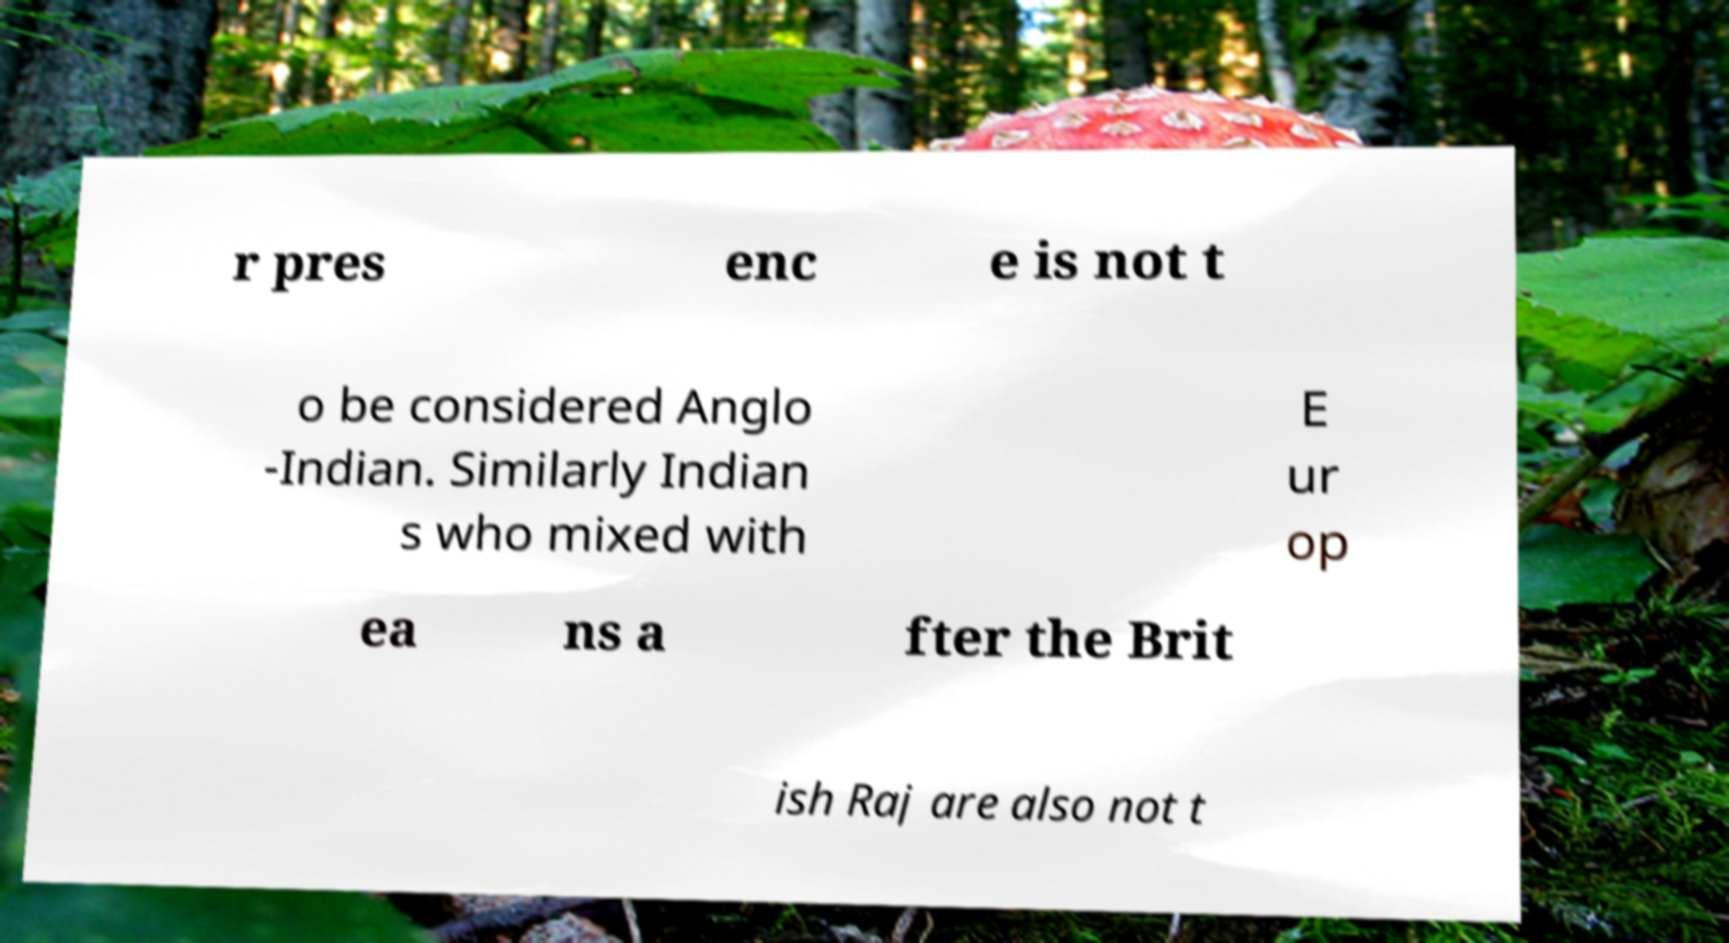Could you extract and type out the text from this image? r pres enc e is not t o be considered Anglo -Indian. Similarly Indian s who mixed with E ur op ea ns a fter the Brit ish Raj are also not t 